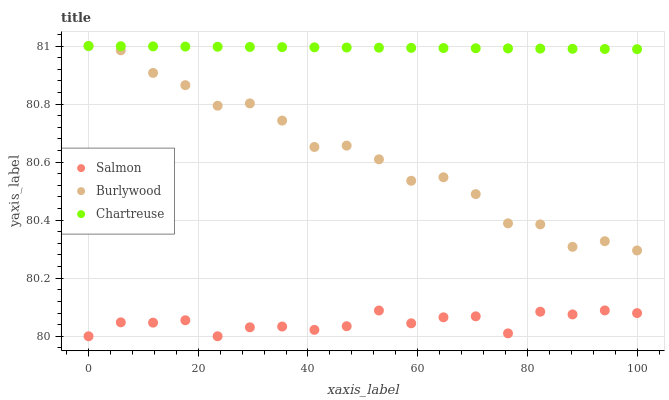Does Salmon have the minimum area under the curve?
Answer yes or no. Yes. Does Chartreuse have the maximum area under the curve?
Answer yes or no. Yes. Does Chartreuse have the minimum area under the curve?
Answer yes or no. No. Does Salmon have the maximum area under the curve?
Answer yes or no. No. Is Chartreuse the smoothest?
Answer yes or no. Yes. Is Burlywood the roughest?
Answer yes or no. Yes. Is Salmon the smoothest?
Answer yes or no. No. Is Salmon the roughest?
Answer yes or no. No. Does Salmon have the lowest value?
Answer yes or no. Yes. Does Chartreuse have the lowest value?
Answer yes or no. No. Does Chartreuse have the highest value?
Answer yes or no. Yes. Does Salmon have the highest value?
Answer yes or no. No. Is Salmon less than Chartreuse?
Answer yes or no. Yes. Is Burlywood greater than Salmon?
Answer yes or no. Yes. Does Chartreuse intersect Burlywood?
Answer yes or no. Yes. Is Chartreuse less than Burlywood?
Answer yes or no. No. Is Chartreuse greater than Burlywood?
Answer yes or no. No. Does Salmon intersect Chartreuse?
Answer yes or no. No. 